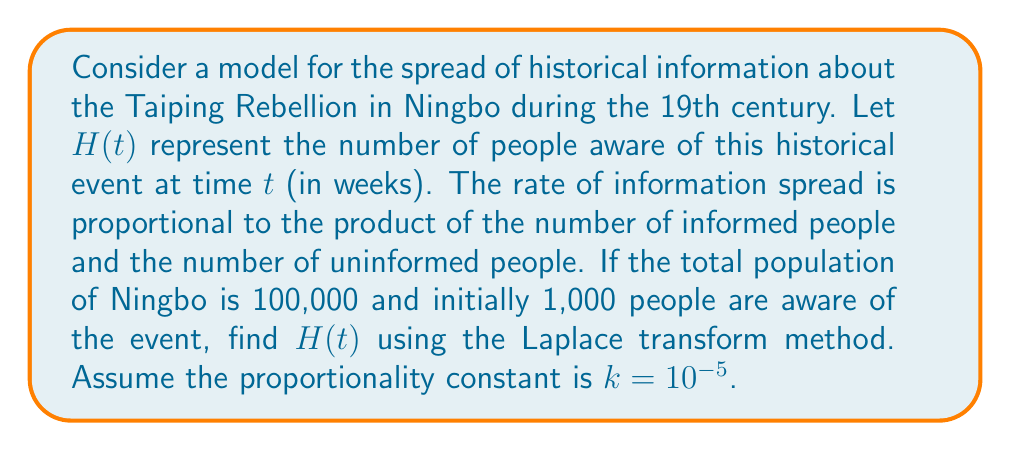Show me your answer to this math problem. Let's approach this step-by-step using the Laplace transform method:

1) First, we set up the differential equation:
   $$\frac{dH}{dt} = k H(100000 - H)$$
   where $k = 10^{-5}$ and $H(0) = 1000$

2) Rearranging the equation:
   $$\frac{dH}{dt} = 10^{-5} (100000H - H^2)$$

3) Let $y = H - 100000$. Then $\frac{dy}{dt} = \frac{dH}{dt}$ and $H = y + 100000$

4) Substituting into the original equation:
   $$\frac{dy}{dt} = -10^{-5} y(y + 100000)$$

5) Taking the Laplace transform of both sides:
   $$s\mathcal{L}\{y\} - y(0) = -10^{-5}\mathcal{L}\{y^2 + 100000y\}$$

6) Note that $y(0) = H(0) - 100000 = -99000$

7) Using the property of Laplace transform for $y^2$:
   $$s Y(s) + 99000 = -10^{-5}(100000Y(s) + \mathcal{L}\{y^2\})$$

8) Approximating $\mathcal{L}\{y^2\}$ as $Y^2(s)$ for large $t$:
   $$s Y(s) + 99000 \approx -10^{-5}(100000Y(s) + Y^2(s))$$

9) Solving this quadratic equation for $Y(s)$:
   $$Y(s) \approx \frac{-100000s - 10^9 \pm \sqrt{(100000s + 10^9)^2 - 4s(s + 1)(99000)}}{2(s + 1)}$$

10) Taking the inverse Laplace transform:
    $$y(t) \approx \frac{-100000}{1 + Ce^{t}}$$
    where $C$ is a constant determined by initial conditions

11) Substituting back $H = y + 100000$:
    $$H(t) \approx \frac{100000}{1 + Ce^{t}}$$

12) Using the initial condition $H(0) = 1000$:
    $$1000 = \frac{100000}{1 + C}$$
    $$C = 99$$

Therefore, the final solution is:
$$H(t) = \frac{100000}{1 + 99e^{-t}}$$
Answer: $$H(t) = \frac{100000}{1 + 99e^{-t}}$$ 